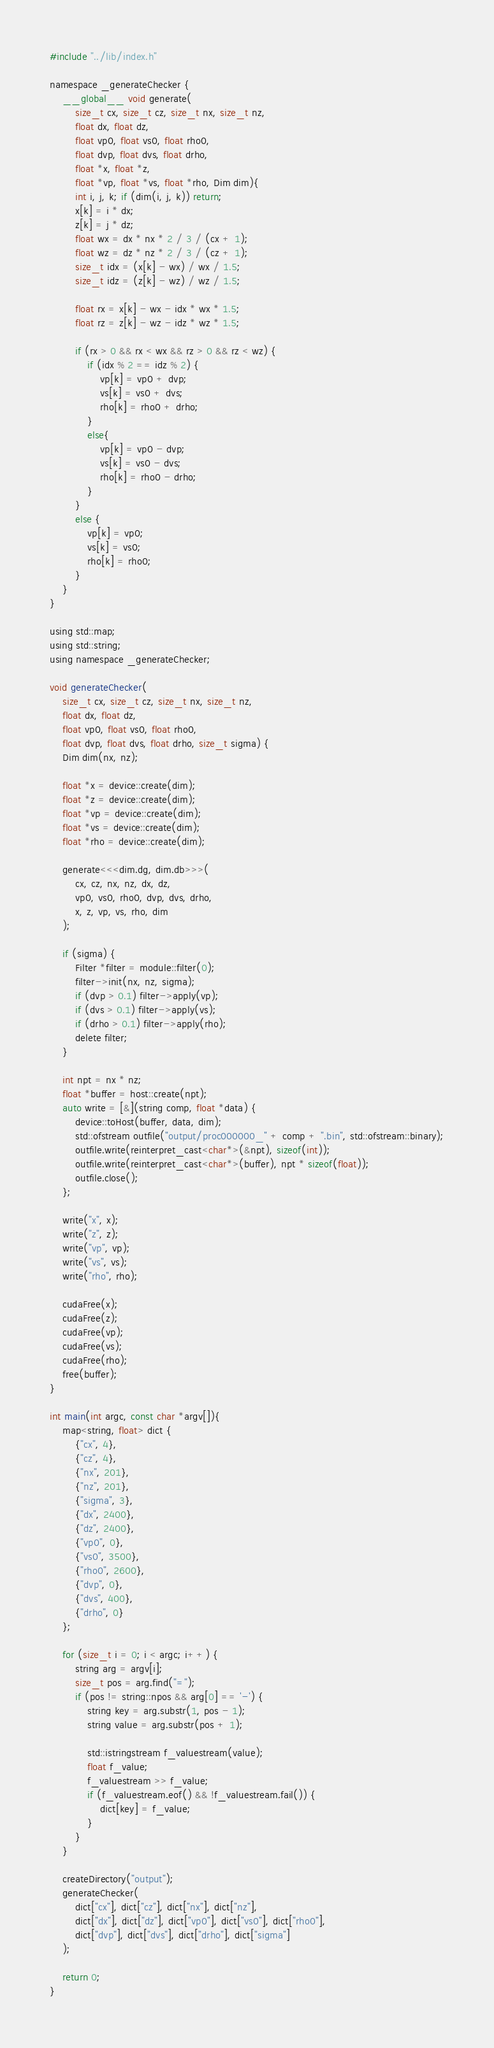<code> <loc_0><loc_0><loc_500><loc_500><_Cuda_>#include "../lib/index.h"

namespace _generateChecker {
	__global__ void generate(
		size_t cx, size_t cz, size_t nx, size_t nz,
		float dx, float dz,
		float vp0, float vs0, float rho0,
		float dvp, float dvs, float drho,
		float *x, float *z,
		float *vp, float *vs, float *rho, Dim dim){
		int i, j, k; if (dim(i, j, k)) return;
		x[k] = i * dx;
		z[k] = j * dz;
		float wx = dx * nx * 2 / 3 / (cx + 1);
		float wz = dz * nz * 2 / 3 / (cz + 1);
		size_t idx = (x[k] - wx) / wx / 1.5;
		size_t idz = (z[k] - wz) / wz / 1.5;

		float rx = x[k] - wx - idx * wx * 1.5;
		float rz = z[k] - wz - idz * wz * 1.5;

		if (rx > 0 && rx < wx && rz > 0 && rz < wz) {
			if (idx % 2 == idz % 2) {
				vp[k] = vp0 + dvp;
				vs[k] = vs0 + dvs;
				rho[k] = rho0 + drho;
			}
			else{
				vp[k] = vp0 - dvp;
				vs[k] = vs0 - dvs;
				rho[k] = rho0 - drho;
			}
		}
		else {
			vp[k] = vp0;
			vs[k] = vs0;
			rho[k] = rho0;
		}
	}
}

using std::map;
using std::string;
using namespace _generateChecker;

void generateChecker(
	size_t cx, size_t cz, size_t nx, size_t nz,
	float dx, float dz,
	float vp0, float vs0, float rho0,
	float dvp, float dvs, float drho, size_t sigma) {
	Dim dim(nx, nz);

	float *x = device::create(dim);
	float *z = device::create(dim);
	float *vp = device::create(dim);
	float *vs = device::create(dim);
	float *rho = device::create(dim);

	generate<<<dim.dg, dim.db>>>(
		cx, cz, nx, nz, dx, dz,
		vp0, vs0, rho0, dvp, dvs, drho,
		x, z, vp, vs, rho, dim
	);

	if (sigma) {
		Filter *filter = module::filter(0);
		filter->init(nx, nz, sigma);
		if (dvp > 0.1) filter->apply(vp);
		if (dvs > 0.1) filter->apply(vs);
		if (drho > 0.1) filter->apply(rho);
		delete filter;
	}

	int npt = nx * nz;
	float *buffer = host::create(npt);
	auto write = [&](string comp, float *data) {
		device::toHost(buffer, data, dim);
		std::ofstream outfile("output/proc000000_" + comp + ".bin", std::ofstream::binary);
		outfile.write(reinterpret_cast<char*>(&npt), sizeof(int));
		outfile.write(reinterpret_cast<char*>(buffer), npt * sizeof(float));
		outfile.close();
	};

	write("x", x);
	write("z", z);
	write("vp", vp);
	write("vs", vs);
	write("rho", rho);

	cudaFree(x);
	cudaFree(z);
	cudaFree(vp);
	cudaFree(vs);
	cudaFree(rho);
	free(buffer);
}

int main(int argc, const char *argv[]){
	map<string, float> dict {
		{"cx", 4},
		{"cz", 4},
		{"nx", 201},
		{"nz", 201},
		{"sigma", 3},
		{"dx", 2400},
		{"dz", 2400},
		{"vp0", 0},
		{"vs0", 3500},
		{"rho0", 2600},
		{"dvp", 0},
		{"dvs", 400},
		{"drho", 0}
	};

	for (size_t i = 0; i < argc; i++) {
		string arg = argv[i];
		size_t pos = arg.find("=");
		if (pos != string::npos && arg[0] == '-') {
			string key = arg.substr(1, pos - 1);
			string value = arg.substr(pos + 1);

			std::istringstream f_valuestream(value);
			float f_value;
			f_valuestream >> f_value;
			if (f_valuestream.eof() && !f_valuestream.fail()) {
				dict[key] = f_value;
			}
		}
	}

	createDirectory("output");
	generateChecker(
		dict["cx"], dict["cz"], dict["nx"], dict["nz"],
		dict["dx"], dict["dz"], dict["vp0"], dict["vs0"], dict["rho0"],
		dict["dvp"], dict["dvs"], dict["drho"], dict["sigma"]
	);

	return 0;
}
</code> 